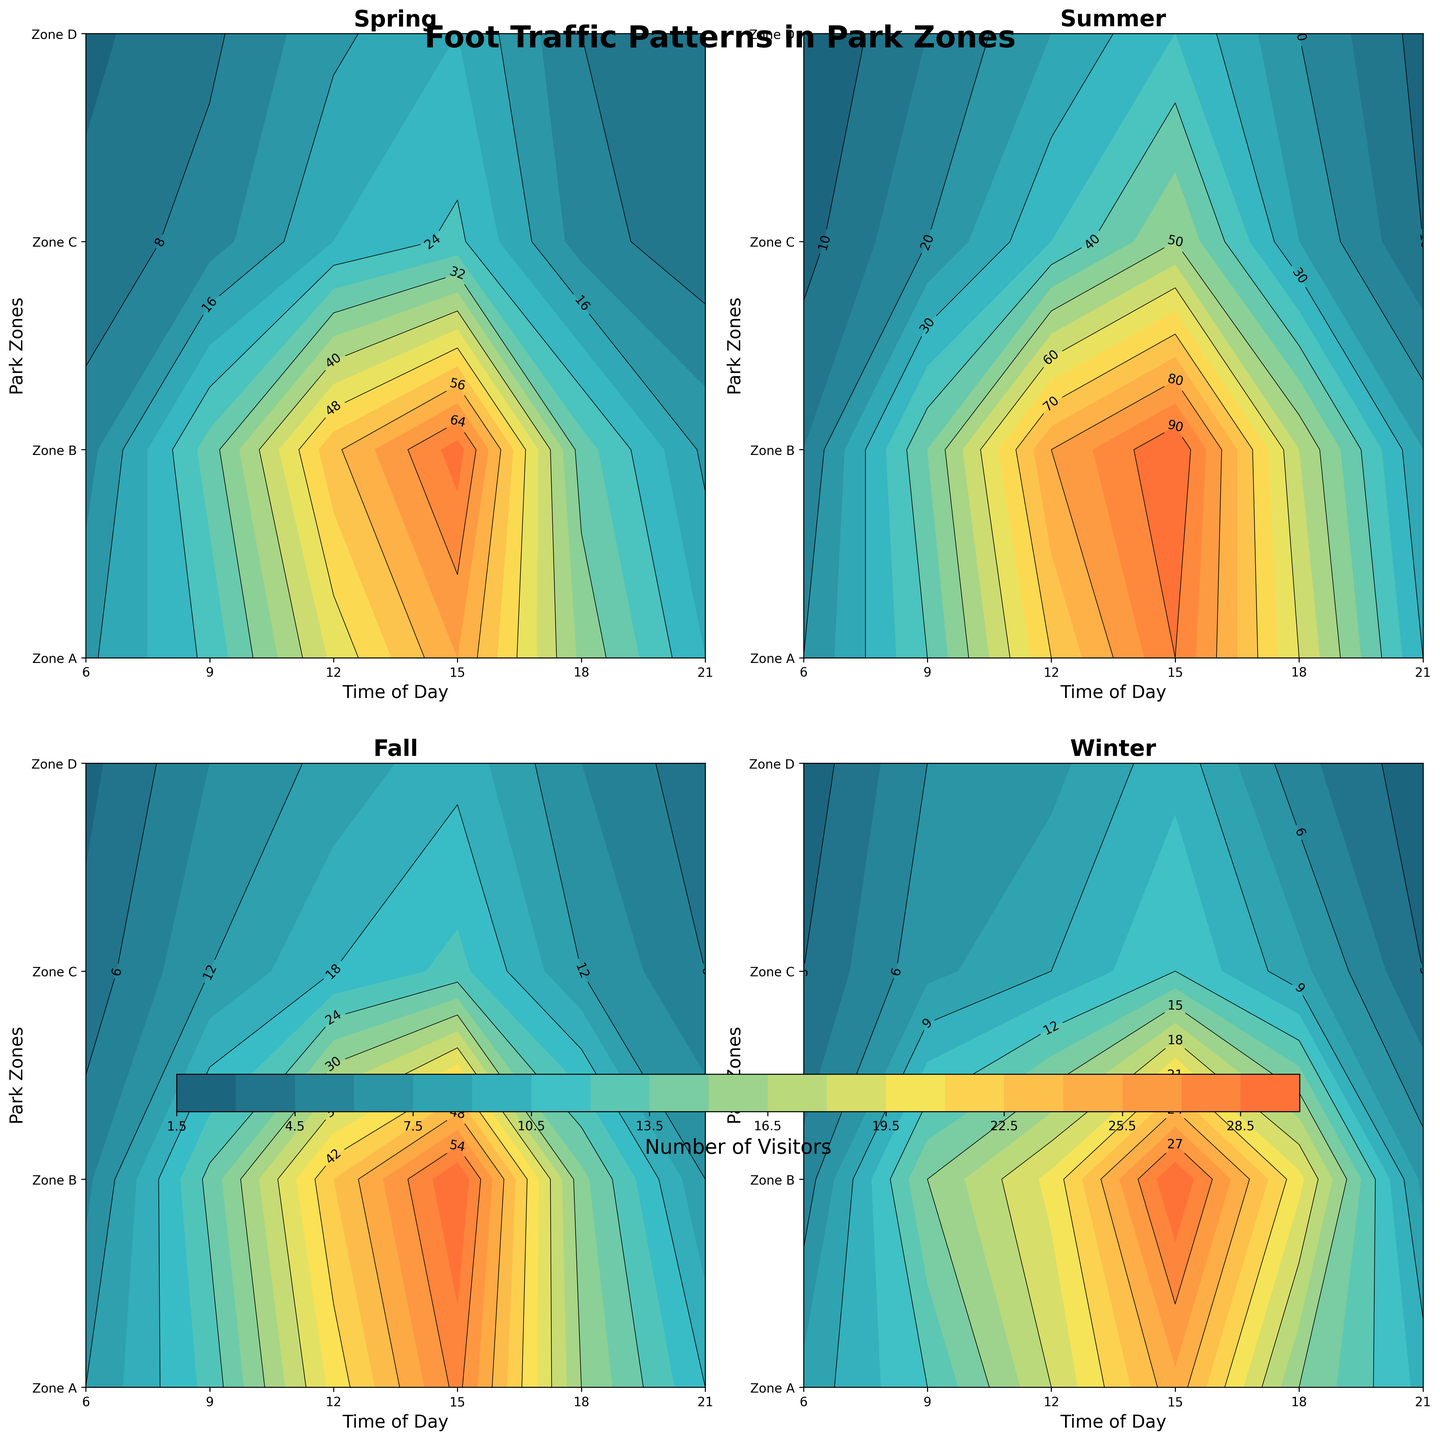How does foot traffic in Zone A during Summer at 15:00 compare to the foot traffic in Zone A during Spring at 15:00? First, look at the foot traffic data for Zone A at 15:00 in Summer and Spring. From the plot, in Summer it's 90 visitors, and in Spring it's 60 visitors. Compare the two values to see that Summer has more visitors.
Answer: Summer has more visitors At what time of day do we see the peak foot traffic in Zone B during Fall? Inspect the contour plot for Zone B in the Fall pane. Identify the highest contour level, which represents maximum foot traffic. The peak happens at 15:00 with 60 visitors.
Answer: 15:00 What's the general trend of foot traffic in Zone D throughout the day in Winter? Examine the contour levels for Zone D in the Winter pane. Early in the morning (06:00), traffic is low with 2 visitors, peaks around 15:00 with 10 visitors, then decreases again by 21:00 to 2 visitors. Traffic initially increases and then decreases.
Answer: Traffic peaks midday Which season shows the least variation in foot traffic in Zone C? Compare the contour plots for Zone C across all seasons. Look for the season where contour levels are most uniform. Winter shows the least variation, with values ranging modestly from 3 to 12 visitors.
Answer: Winter In which season does Zone A experience the highest foot traffic, and at what time? Find the highest contour level in Zone A across all seasons. The highest foot traffic occurs in Summer at 15:00 with 90 visitors.
Answer: Summer at 15:00 What's the average foot traffic for Zone B in Spring at 15:00 and 18:00? From the Spring pane, note the visitor counts for Zone B at 15:00 (70) and 18:00 (30). Calculate the average by summing these values and dividing by 2. Average is (70 + 30) / 2 = 50.
Answer: 50 Which zones experience the least foot traffic at 06:00 across all seasons? Check the contour levels for each zone at 06:00 in all seasonal panes. Zone D consistently has the lowest visitors at 6:00, with 3 visitors in Spring, 5 in Summer, 2 in Fall, and 2 in Winter.
Answer: Zone D How does the foot traffic in Zone C at 12:00 compare to 18:00 across all seasons? Compare visitor counts for Zone C at 12:00 with 18:00 in each season: Spring (20 vs. 10), Summer (35 vs. 25), Fall (18 vs. 12), and Winter (9 vs. 8). In each season, the foot traffic at 12:00 is higher.
Answer: 12:00 has more visitors What's the difference in foot traffic between Zone A and Zone C during Summer at 09:00? Check the contour levels for Zone A (40 visitors) and Zone C (20 visitors) at 09:00 in Summer. Subtract the visitors in Zone C from Zone A. The difference is 40 - 20 = 20.
Answer: 20 